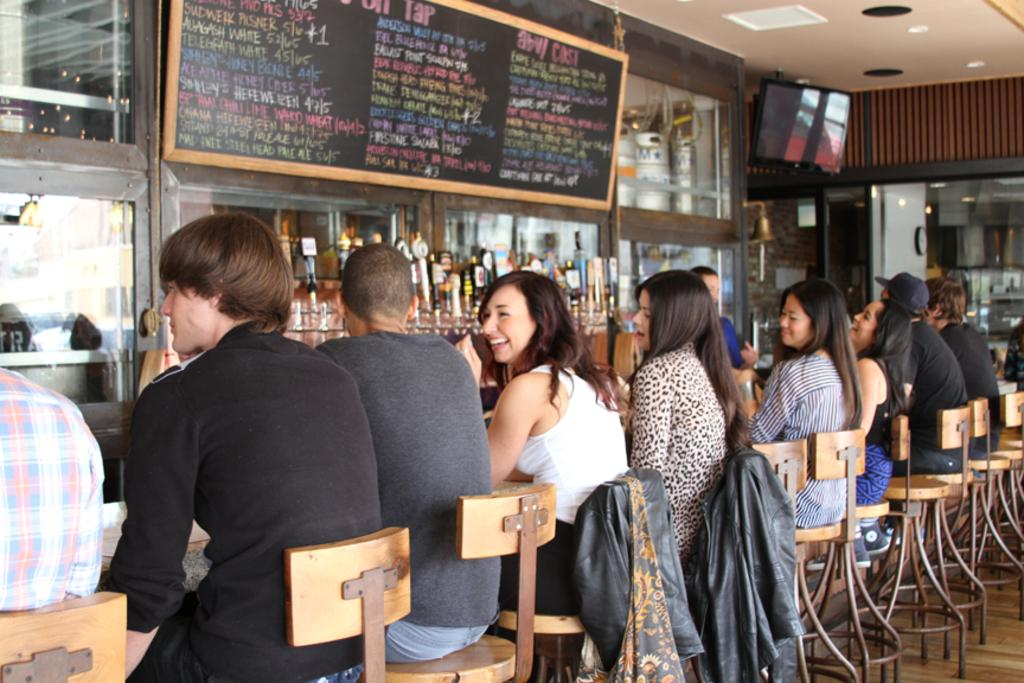What is hanging in the image? There is a banner in the image. What objects can be seen on the banner? The provided facts do not specify any objects on the banner. What else is visible in the image besides the banner? There are bottles and a rack visible in the image. What are the people in the image doing? The people in the image are sitting on chairs. What type of advertisement is being displayed on the banner? The provided facts do not specify any advertisement or content on the banner. 